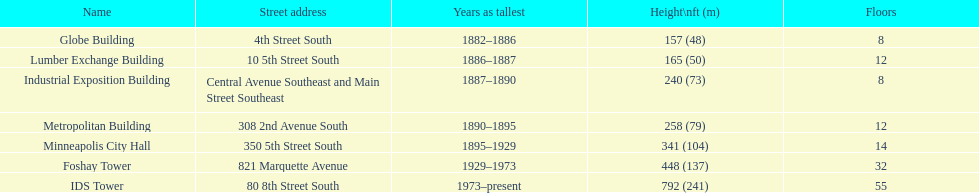How tall is it to the top of the ids tower in feet? 792. 